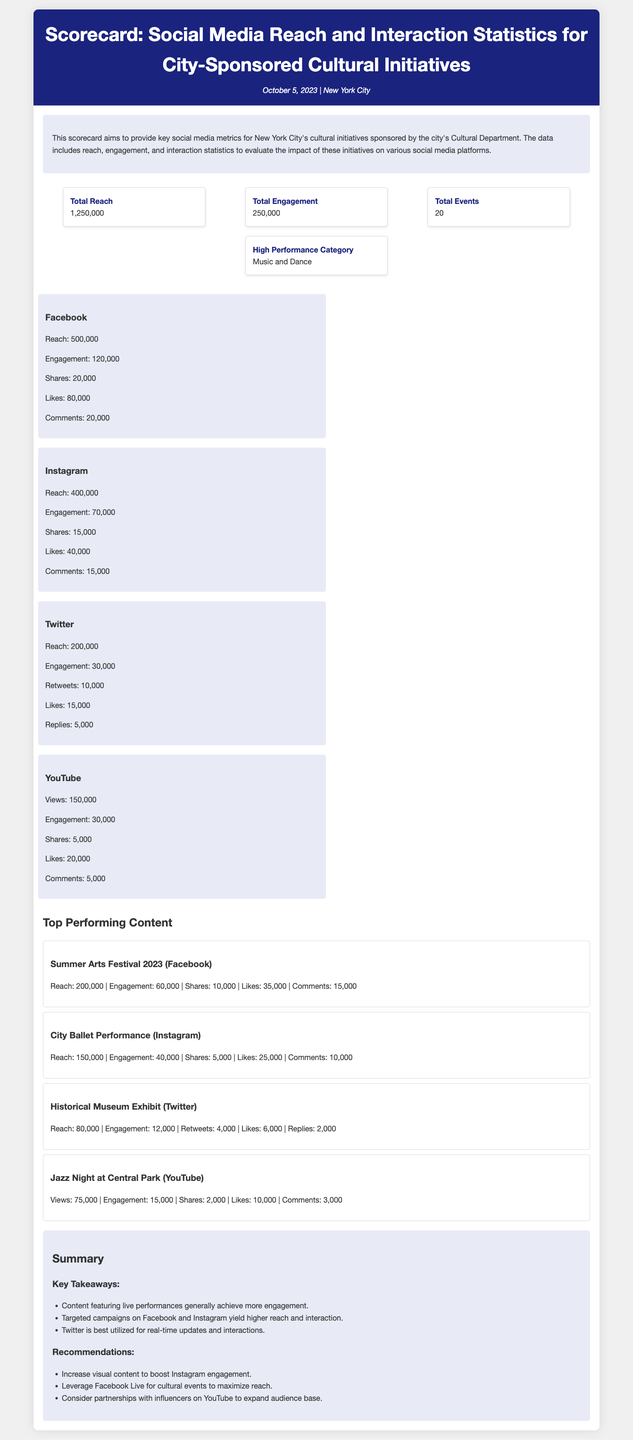What is the total reach? The total reach is the cumulative reach of all social media platforms listed in the document, which is 1,250,000.
Answer: 1,250,000 What platform had the highest engagement? The platform with the highest engagement is Facebook, with a total engagement of 120,000.
Answer: Facebook How many events were listed? The document states that there were 20 events conducted as part of the cultural initiatives.
Answer: 20 What is the high-performance category? The high-performance category according to the document is Music and Dance.
Answer: Music and Dance What was the reach of the City Ballet Performance on Instagram? The reach of the City Ballet Performance on Instagram is detailed as 150,000.
Answer: 150,000 Which platform had the lowest reach? The platform with the lowest reach is Twitter, with a total reach of 200,000.
Answer: Twitter What percentage of the total engagement came from Facebook? The total engagement from Facebook is 120,000, which accounts for a significant percentage of the total engagement of 250,000. The calculation yields 48%.
Answer: 48% What is the recommended strategy for increasing engagement on Instagram? The document suggests increasing visual content as a strategy to boost engagement on Instagram.
Answer: Increase visual content Which content performed best on Facebook? The Summer Arts Festival 2023 is highlighted as the top performing content on Facebook in terms of metrics listed.
Answer: Summer Arts Festival 2023 